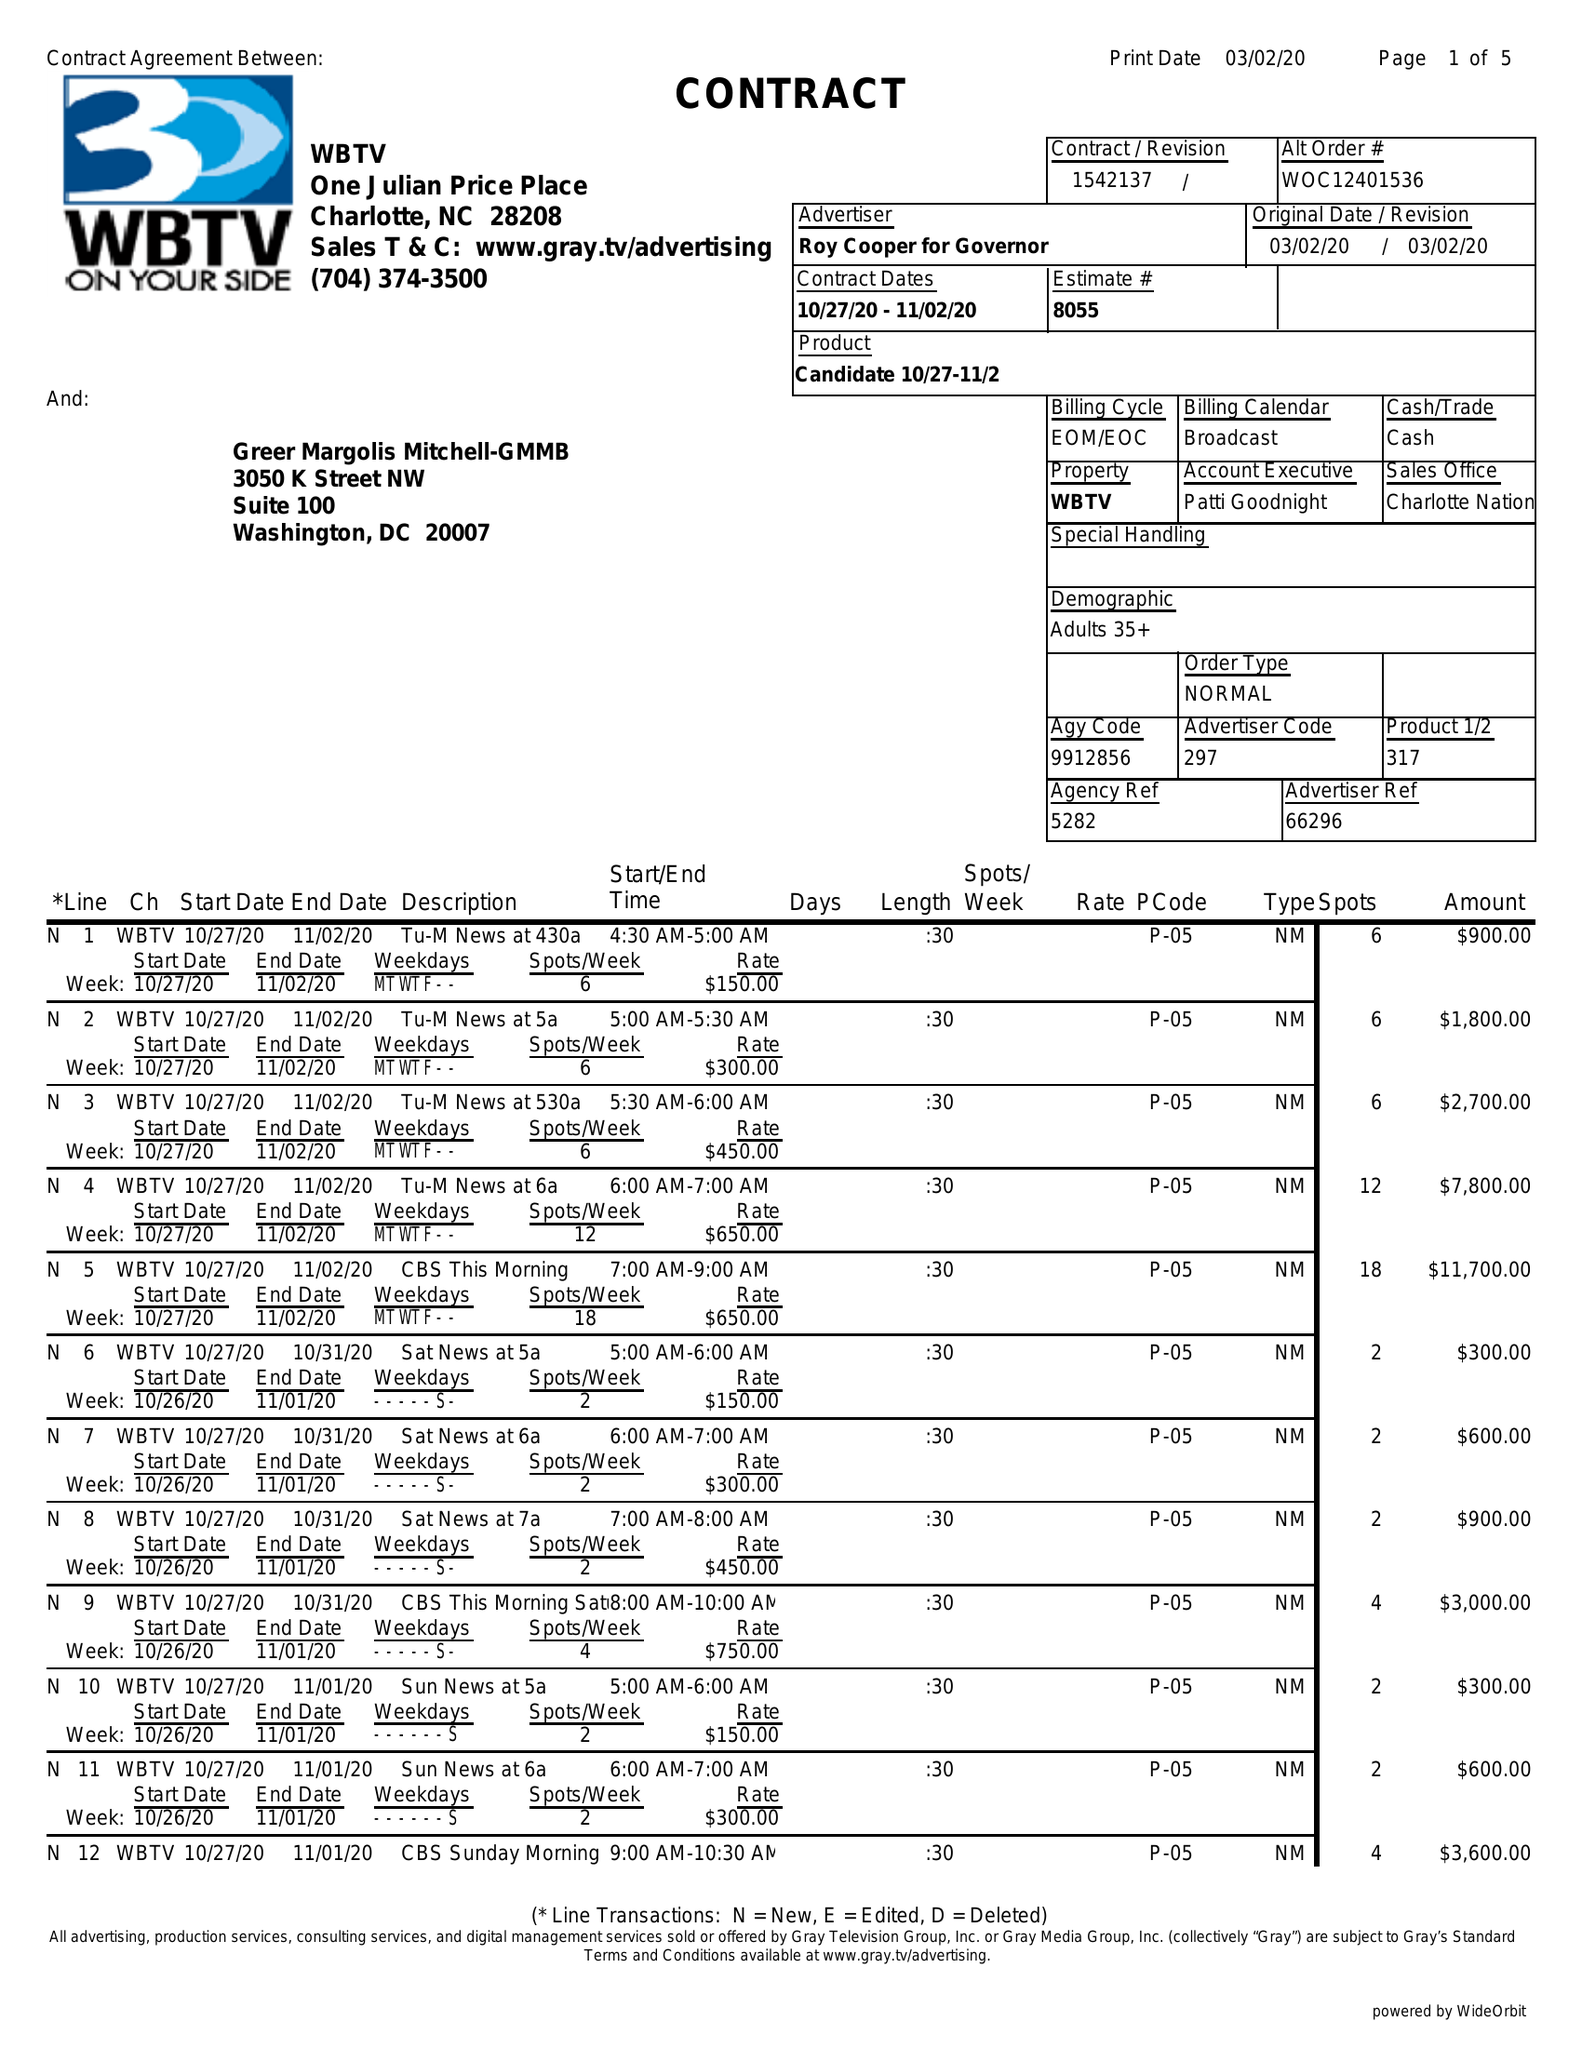What is the value for the flight_from?
Answer the question using a single word or phrase. 10/27/20 